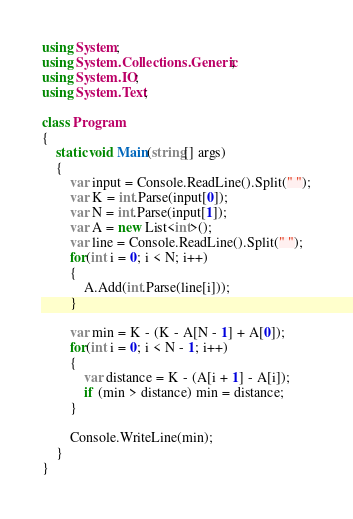Convert code to text. <code><loc_0><loc_0><loc_500><loc_500><_C#_>using System;
using System.Collections.Generic;
using System.IO;
using System.Text;

class Program
{
    static void Main(string[] args)
    {
        var input = Console.ReadLine().Split(" ");
        var K = int.Parse(input[0]);
        var N = int.Parse(input[1]);
        var A = new List<int>();
        var line = Console.ReadLine().Split(" ");
        for(int i = 0; i < N; i++)
        {
            A.Add(int.Parse(line[i]));
        }

        var min = K - (K - A[N - 1] + A[0]);
        for(int i = 0; i < N - 1; i++)
        {
            var distance = K - (A[i + 1] - A[i]);
            if (min > distance) min = distance;
        }

        Console.WriteLine(min);
    }
}
</code> 